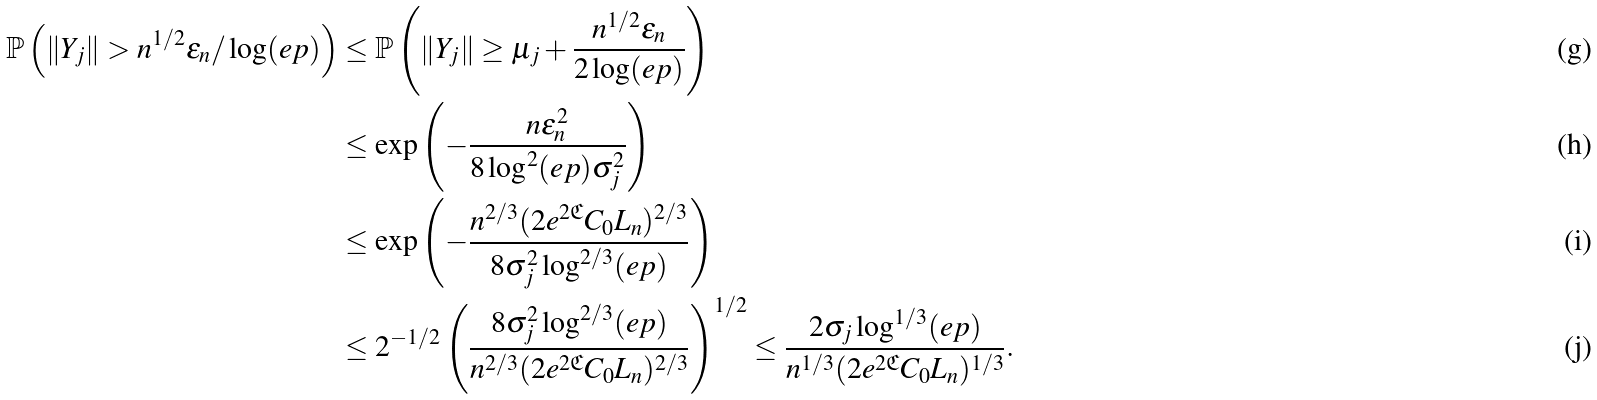<formula> <loc_0><loc_0><loc_500><loc_500>\mathbb { P } \left ( \| Y _ { j } \| > n ^ { 1 / 2 } \varepsilon _ { n } / \log ( e p ) \right ) & \leq \mathbb { P } \left ( \| Y _ { j } \| \geq \mu _ { j } + \frac { n ^ { 1 / 2 } \varepsilon _ { n } } { 2 \log ( e p ) } \right ) \\ & \leq \exp \left ( - \frac { n \varepsilon _ { n } ^ { 2 } } { 8 \log ^ { 2 } ( e p ) \sigma _ { j } ^ { 2 } } \right ) \\ & \leq \exp \left ( - \frac { n ^ { 2 / 3 } ( 2 e ^ { 2 \mathfrak { C } } C _ { 0 } L _ { n } ) ^ { 2 / 3 } } { 8 \sigma _ { j } ^ { 2 } \log ^ { 2 / 3 } ( e p ) } \right ) \\ & \leq 2 ^ { - 1 / 2 } \left ( \frac { 8 \sigma _ { j } ^ { 2 } \log ^ { 2 / 3 } ( e p ) } { n ^ { 2 / 3 } ( 2 e ^ { 2 \mathfrak { C } } C _ { 0 } L _ { n } ) ^ { 2 / 3 } } \right ) ^ { 1 / 2 } \leq \frac { 2 \sigma _ { j } \log ^ { 1 / 3 } ( e p ) } { n ^ { 1 / 3 } ( 2 e ^ { 2 \mathfrak { C } } C _ { 0 } L _ { n } ) ^ { 1 / 3 } } .</formula> 